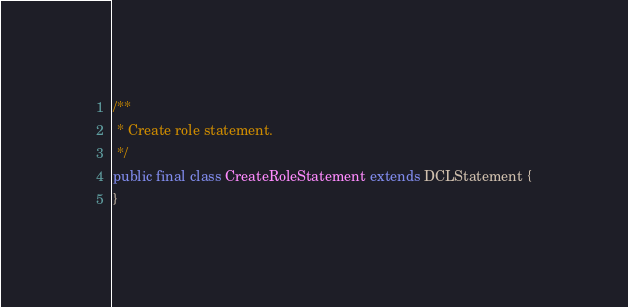<code> <loc_0><loc_0><loc_500><loc_500><_Java_>
/**
 * Create role statement.
 */
public final class CreateRoleStatement extends DCLStatement {
}
</code> 